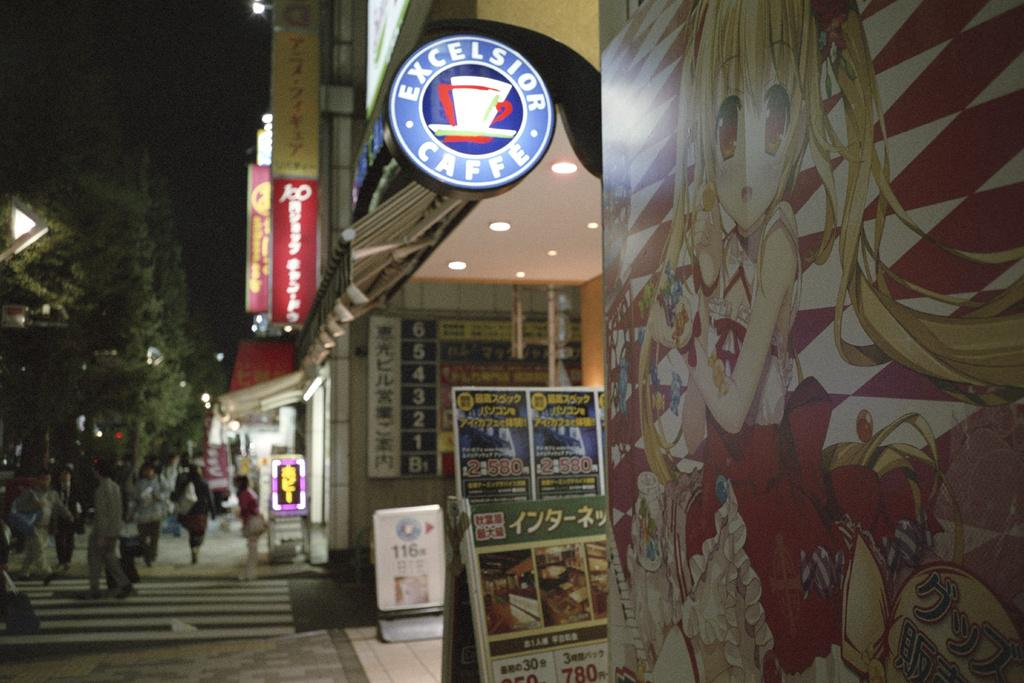<image>
Summarize the visual content of the image. A street in an Asian country with a sign for Excelsior Caffe 